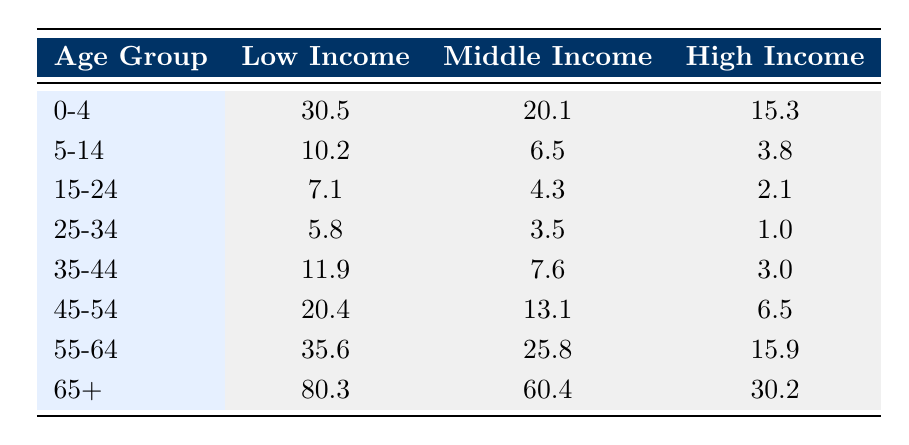What is the mortality rate for the age group 25-34 in low income? According to the table, under the Low Income category for the age group 25-34, the specified mortality rate is 5.8.
Answer: 5.8 Which income level has the highest mortality rate for the age group 65+? Reviewing the row for age group 65+, Low Income has a mortality rate of 80.3, which is higher than Middle Income (60.4) and High Income (30.2).
Answer: Low Income What is the difference in mortality rates between the age groups 0-4 and 5-14 for middle income? The mortality rate for Middle Income in the age group 0-4 is 20.1, and for 5-14 it is 6.5. Calculating the difference: 20.1 - 6.5 equals 13.6.
Answer: 13.6 Is the mortality rate for the age group 55-64 higher in low income than in high income? The mortality rate for Low Income in the age group 55-64 is 35.6, while for High Income it is 15.9. Since 35.6 is greater than 15.9, the statement is true.
Answer: Yes What is the average mortality rate across all age groups for high income? To find the average, sum the mortality rates for High Income: 15.3 + 3.8 + 2.1 + 1.0 + 3.0 + 6.5 + 15.9 + 30.2 equals 77.8. There are 8 age groups, so the average is 77.8 / 8 = 9.725.
Answer: 9.725 How does the mortality rate for the age group 45-54 compare between low and middle income? For Low Income, the mortality rate in the age group 45-54 is 20.4, while for Middle Income it is 13.1. The Low Income rate is higher by subtracting these two figures: 20.4 - 13.1 gives 7.3.
Answer: 7.3 (Low income is higher) What is the highest mortality rate recorded in the entire table? By scanning through all the mortality rates listed in the table, the highest figure appears in the Low Income category for the age group 65+, which is 80.3.
Answer: 80.3 Are the mortality rates for middle income higher than those for high income in the age group 35-44? For Middle Income, the mortality rate in this age group is 7.6, while for High Income it is 3.0. Since 7.6 is greater than 3.0, the statement is true.
Answer: Yes 